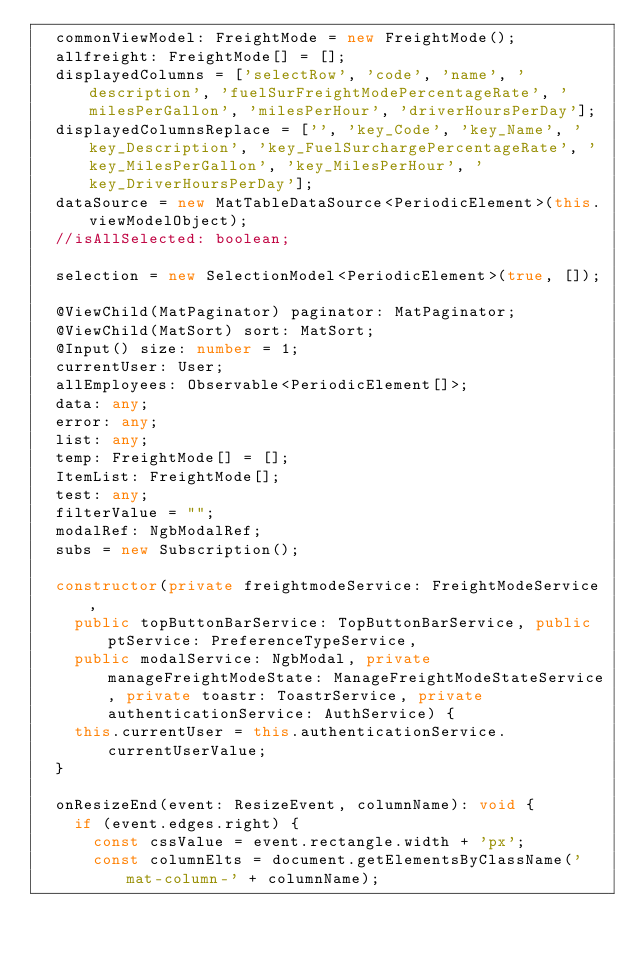<code> <loc_0><loc_0><loc_500><loc_500><_TypeScript_>  commonViewModel: FreightMode = new FreightMode();
  allfreight: FreightMode[] = [];
  displayedColumns = ['selectRow', 'code', 'name', 'description', 'fuelSurFreightModePercentageRate', 'milesPerGallon', 'milesPerHour', 'driverHoursPerDay'];
  displayedColumnsReplace = ['', 'key_Code', 'key_Name', 'key_Description', 'key_FuelSurchargePercentageRate', 'key_MilesPerGallon', 'key_MilesPerHour', 'key_DriverHoursPerDay'];
  dataSource = new MatTableDataSource<PeriodicElement>(this.viewModelObject);
  //isAllSelected: boolean;

  selection = new SelectionModel<PeriodicElement>(true, []);

  @ViewChild(MatPaginator) paginator: MatPaginator;
  @ViewChild(MatSort) sort: MatSort;
  @Input() size: number = 1;
  currentUser: User;
  allEmployees: Observable<PeriodicElement[]>;
  data: any;
  error: any;
  list: any;
  temp: FreightMode[] = [];
  ItemList: FreightMode[];
  test: any;
  filterValue = "";
  modalRef: NgbModalRef;
  subs = new Subscription();

  constructor(private freightmodeService: FreightModeService,
    public topButtonBarService: TopButtonBarService, public ptService: PreferenceTypeService,
    public modalService: NgbModal, private manageFreightModeState: ManageFreightModeStateService, private toastr: ToastrService, private authenticationService: AuthService) {
    this.currentUser = this.authenticationService.currentUserValue;
  }

  onResizeEnd(event: ResizeEvent, columnName): void {
    if (event.edges.right) {
      const cssValue = event.rectangle.width + 'px';
      const columnElts = document.getElementsByClassName('mat-column-' + columnName);</code> 